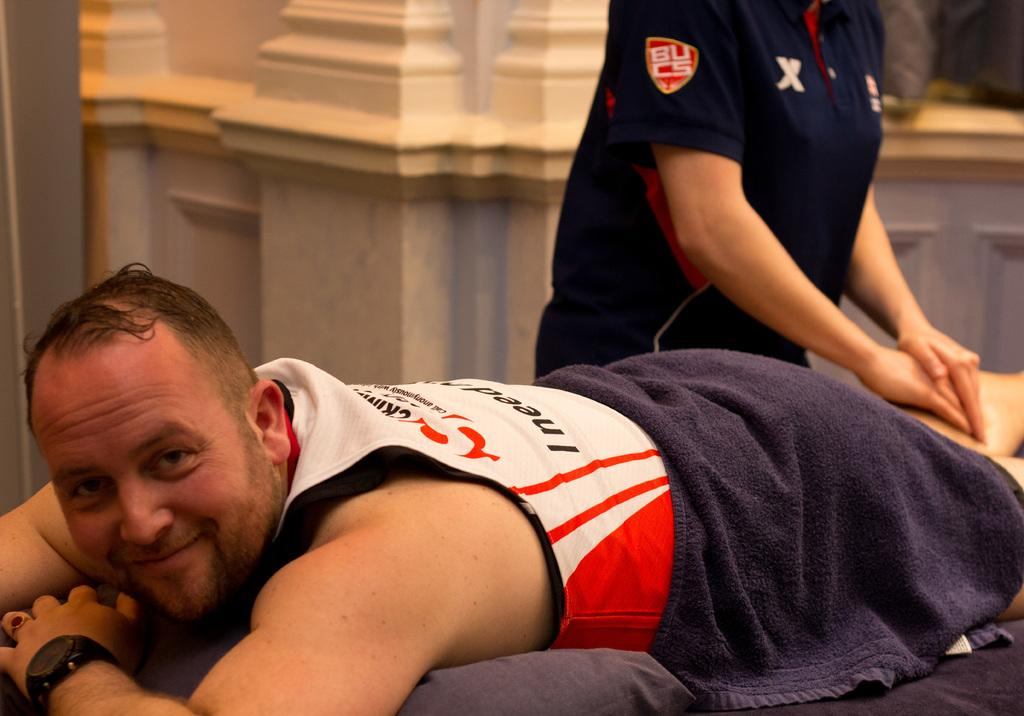<image>
Describe the image concisely. a man laying on a table getting a massage from someone wearing a blue shirt with a BUCS patch on the sleeve 